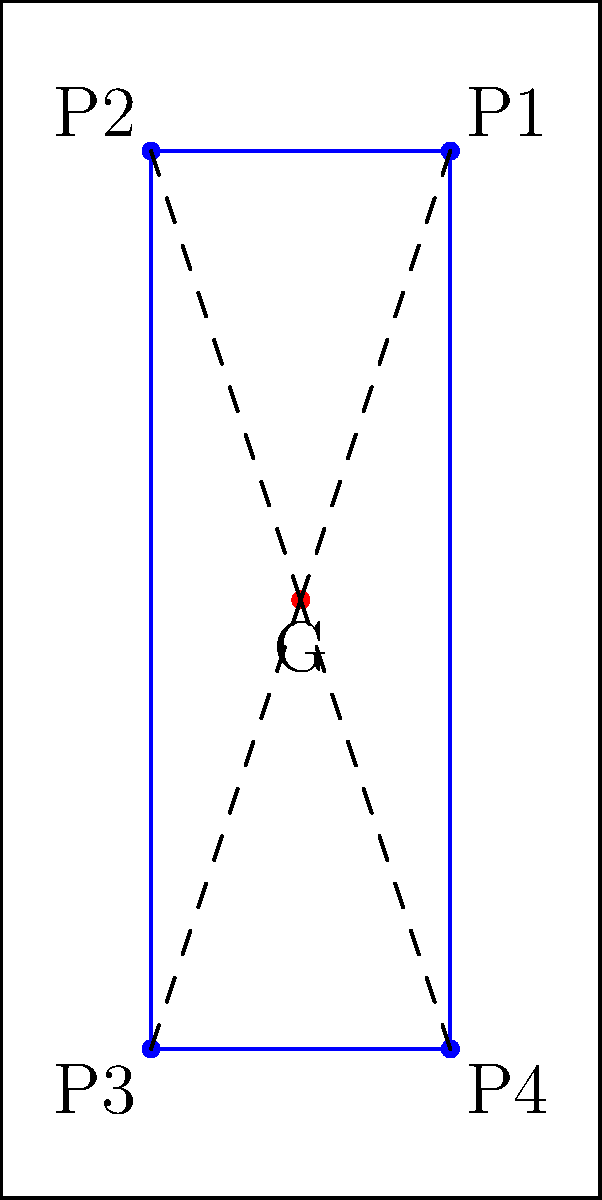In the diagram, G represents the goalkeeper's position, and P1, P2, P3, and P4 are the positions of four defenders forming a rectangular shape. If the goal line is 8 units wide and 4 units high, what is the largest possible gap (in square units) between any two adjacent defenders that an opponent could exploit for a shot on goal? To solve this problem, we need to follow these steps:

1) First, we need to calculate the distances between adjacent defenders:
   - Distance P1 to P2: $2$ units
   - Distance P2 to P3: $6$ units
   - Distance P3 to P4: $2$ units
   - Distance P4 to P1: $6$ units

2) The largest gap is between P2 and P3 or P4 and P1, both $6$ units.

3) Now, we need to calculate the angle this gap subtends at the goal (point G):
   - The defenders form a rectangle $2$ units wide and $6$ units high
   - Using the arctangent function: $\theta = 2 * \arctan(\frac{1}{3}) \approx 36.87°$

4) The area of this sector can be calculated using the formula:
   $A = \frac{1}{2}r^2\theta$, where $r$ is the distance from G to the midpoint of P2P3 (or P4P1).

5) $r$ can be calculated using the Pythagorean theorem:
   $r = \sqrt{3^2 + 1^2} = \sqrt{10} \approx 3.16$ units

6) Now we can calculate the area:
   $A = \frac{1}{2} * (\sqrt{10})^2 * \frac{36.87 * \pi}{180} \approx 5.09$ square units

Therefore, the largest possible gap is approximately 5.09 square units.
Answer: $5.09$ square units 